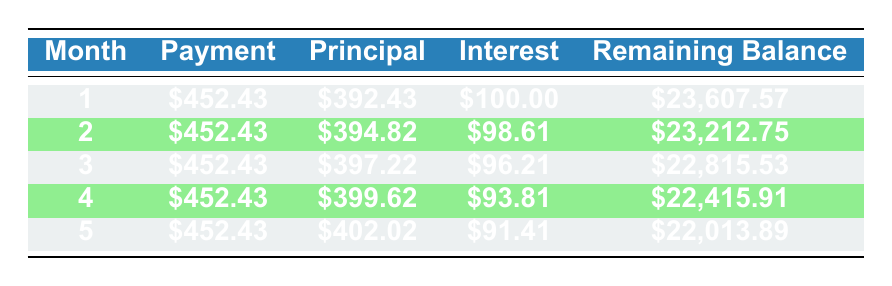What is the total monthly payment for the vehicle? The total monthly payment for the vehicle is listed as $452.43 in the monthly payment column for all months in the table.
Answer: 452.43 How much was paid towards the principal in month 3? In month 3, the principal payment listed in the table is $397.22.
Answer: 397.22 What is the interest payment in month 2? The interest payment for month 2 is clearly stated as $98.61 in the interest payment column of the table.
Answer: 98.61 What is the remaining balance after month 4? For month 4, the remaining balance is indicated in the table as $22,415.91.
Answer: 22,415.91 If you add up the principal payments from month 1 to month 5, what is the total amount paid towards the principal? The principal payments from the table are $392.43, $394.82, $397.22, $399.62, and $402.02. Adding these gives a total of 392.43 + 394.82 + 397.22 + 399.62 + 402.02 = 1986.11.
Answer: 1986.11 Is the interest payment in month 1 greater than $100? The interest payment in month 1 is listed as $100.00, so it is not greater than $100.
Answer: No What is the total remaining balance after the first month? The remaining balance after the first month is provided in the table as $23,607.57.
Answer: 23,607.57 What is the difference in principal payment between month 1 and month 5? The principal payment in month 1 is $392.43 and in month 5 it is $402.02. The difference is calculated as 402.02 - 392.43 = 9.59.
Answer: 9.59 How many months will it take to pay off the loan? The loan term is 5 years, and with 12 months in a year, the total number of months to pay off the loan is 5*12 = 60 months.
Answer: 60 months 